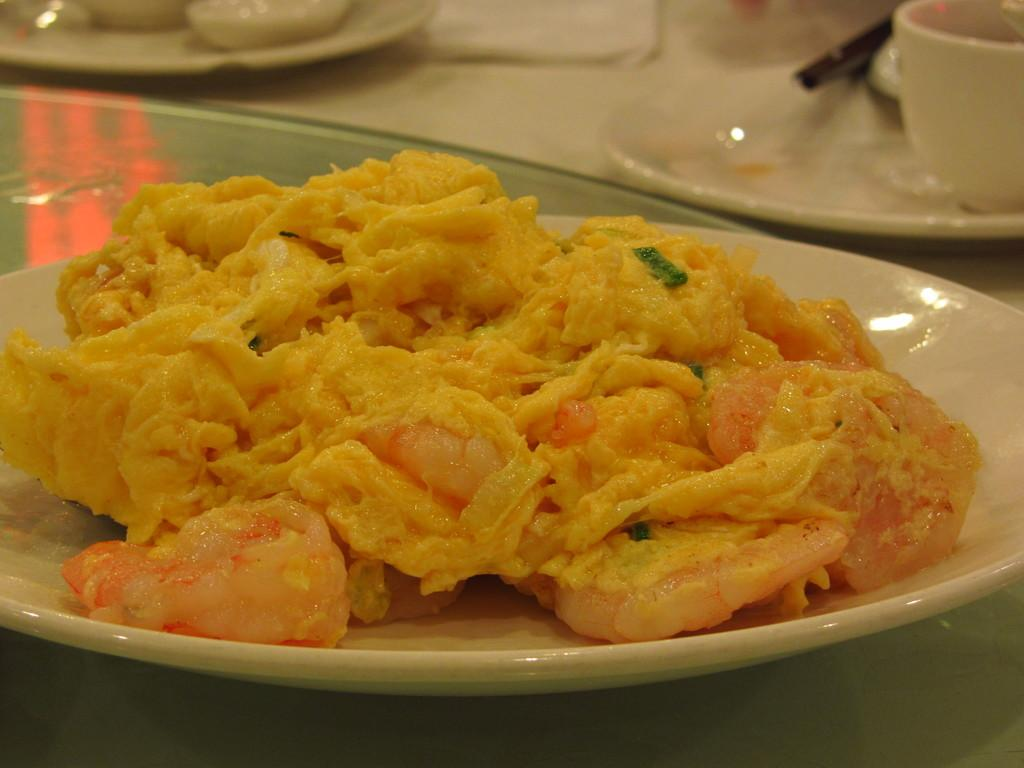What piece of furniture is present in the image? There is a table in the image. What is on the table? There is a plate containing food items, plates, bowls, spoons, and tissue papers on the table. How many plates are on the table? There are plates on the table. How many bowls are on the table? There are bowls on the table. What utensils are on the table? There are spoons on the table. What might be used for wiping or blowing one's nose on the table? There are tissue papers on the table. How many women are visible in the image? There are no women present in the image; it only shows a table with various items on it. What type of house is shown in the image? There is no house shown in the image; it only features a table with various items on it. 